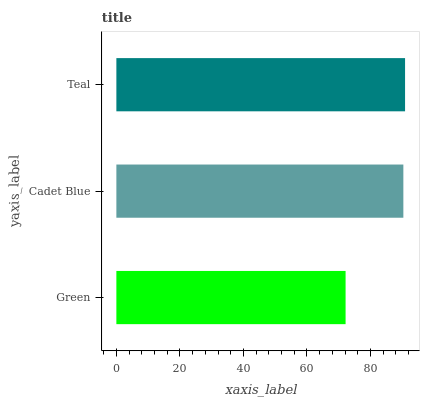Is Green the minimum?
Answer yes or no. Yes. Is Teal the maximum?
Answer yes or no. Yes. Is Cadet Blue the minimum?
Answer yes or no. No. Is Cadet Blue the maximum?
Answer yes or no. No. Is Cadet Blue greater than Green?
Answer yes or no. Yes. Is Green less than Cadet Blue?
Answer yes or no. Yes. Is Green greater than Cadet Blue?
Answer yes or no. No. Is Cadet Blue less than Green?
Answer yes or no. No. Is Cadet Blue the high median?
Answer yes or no. Yes. Is Cadet Blue the low median?
Answer yes or no. Yes. Is Teal the high median?
Answer yes or no. No. Is Green the low median?
Answer yes or no. No. 